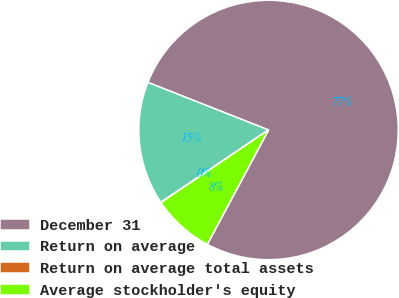Convert chart. <chart><loc_0><loc_0><loc_500><loc_500><pie_chart><fcel>December 31<fcel>Return on average<fcel>Return on average total assets<fcel>Average stockholder's equity<nl><fcel>76.84%<fcel>15.4%<fcel>0.04%<fcel>7.72%<nl></chart> 